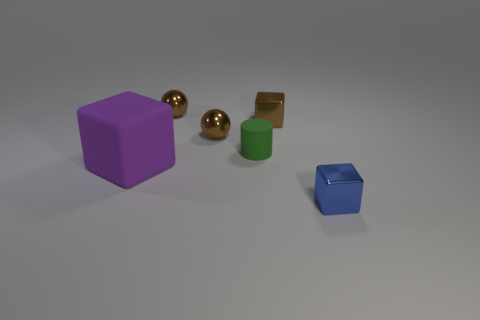Is there any other thing that has the same material as the brown cube?
Ensure brevity in your answer.  Yes. There is a object that is in front of the rubber thing that is to the left of the tiny cylinder; what number of objects are on the left side of it?
Make the answer very short. 5. How many small objects are both in front of the small brown block and to the right of the tiny green rubber object?
Your answer should be very brief. 1. There is a tiny metal thing that is in front of the rubber block; what is its shape?
Provide a short and direct response. Cube. Are there fewer purple things right of the big purple matte cube than metal things that are left of the green object?
Give a very brief answer. Yes. Is the blue cube in front of the green cylinder made of the same material as the tiny cube behind the purple thing?
Offer a very short reply. Yes. The small green matte object is what shape?
Give a very brief answer. Cylinder. Is the number of brown things that are to the left of the cylinder greater than the number of tiny green things in front of the rubber block?
Provide a short and direct response. Yes. Do the matte object that is to the right of the purple thing and the small shiny object in front of the big matte block have the same shape?
Offer a very short reply. No. How many other objects are there of the same size as the purple matte block?
Make the answer very short. 0. 